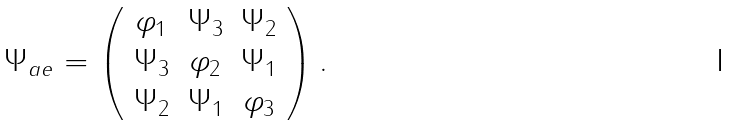Convert formula to latex. <formula><loc_0><loc_0><loc_500><loc_500>\Psi _ { a e } = \left ( \begin{array} { c c c } \varphi _ { 1 } & \Psi _ { 3 } & \Psi _ { 2 } \\ \Psi _ { 3 } & \varphi _ { 2 } & \Psi _ { 1 } \\ \Psi _ { 2 } & \Psi _ { 1 } & \varphi _ { 3 } \\ \end{array} \right ) .</formula> 